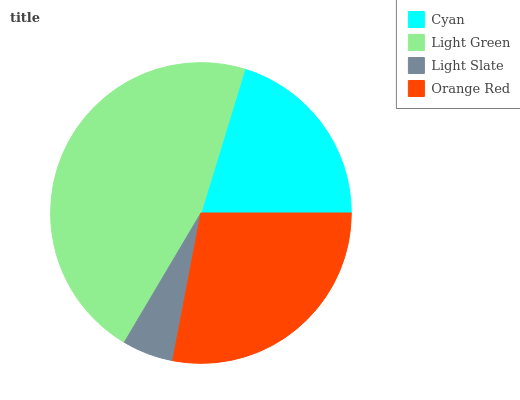Is Light Slate the minimum?
Answer yes or no. Yes. Is Light Green the maximum?
Answer yes or no. Yes. Is Light Green the minimum?
Answer yes or no. No. Is Light Slate the maximum?
Answer yes or no. No. Is Light Green greater than Light Slate?
Answer yes or no. Yes. Is Light Slate less than Light Green?
Answer yes or no. Yes. Is Light Slate greater than Light Green?
Answer yes or no. No. Is Light Green less than Light Slate?
Answer yes or no. No. Is Orange Red the high median?
Answer yes or no. Yes. Is Cyan the low median?
Answer yes or no. Yes. Is Cyan the high median?
Answer yes or no. No. Is Light Green the low median?
Answer yes or no. No. 